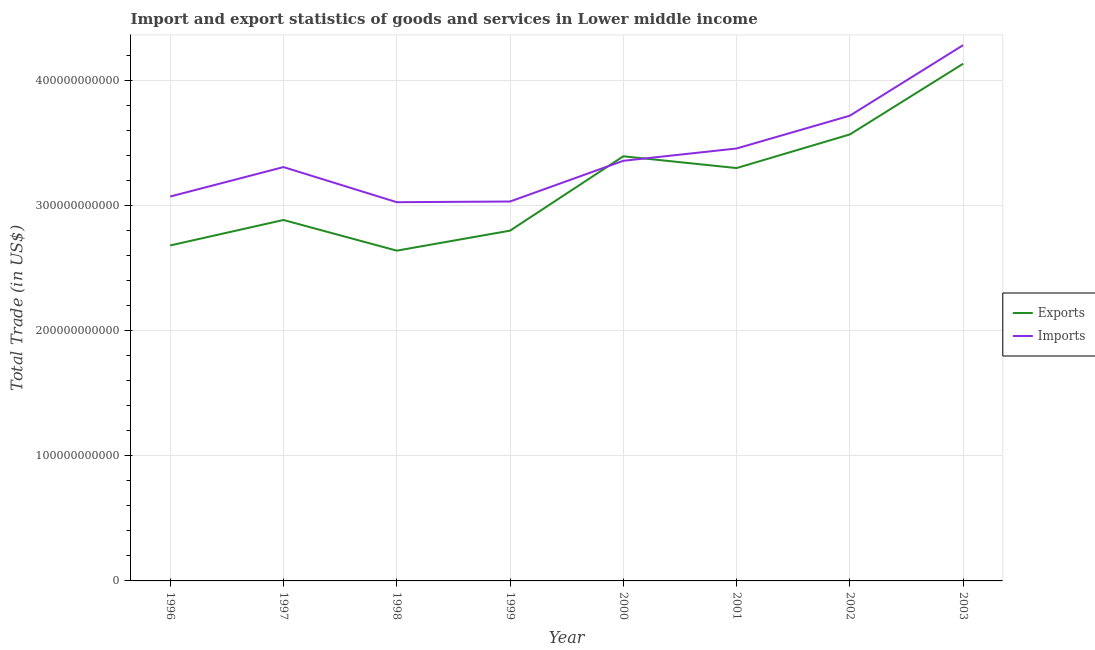How many different coloured lines are there?
Offer a terse response. 2. Does the line corresponding to imports of goods and services intersect with the line corresponding to export of goods and services?
Provide a succinct answer. Yes. What is the export of goods and services in 2002?
Offer a very short reply. 3.57e+11. Across all years, what is the maximum export of goods and services?
Offer a terse response. 4.14e+11. Across all years, what is the minimum imports of goods and services?
Make the answer very short. 3.03e+11. What is the total export of goods and services in the graph?
Your answer should be compact. 2.54e+12. What is the difference between the imports of goods and services in 1999 and that in 2001?
Provide a short and direct response. -4.24e+1. What is the difference between the export of goods and services in 1996 and the imports of goods and services in 2003?
Ensure brevity in your answer.  -1.60e+11. What is the average export of goods and services per year?
Make the answer very short. 3.18e+11. In the year 1997, what is the difference between the imports of goods and services and export of goods and services?
Make the answer very short. 4.23e+1. What is the ratio of the export of goods and services in 1996 to that in 2001?
Offer a very short reply. 0.81. What is the difference between the highest and the second highest export of goods and services?
Your response must be concise. 5.65e+1. What is the difference between the highest and the lowest export of goods and services?
Offer a terse response. 1.49e+11. Is the sum of the imports of goods and services in 2002 and 2003 greater than the maximum export of goods and services across all years?
Give a very brief answer. Yes. Does the imports of goods and services monotonically increase over the years?
Offer a very short reply. No. How many lines are there?
Your answer should be very brief. 2. How many years are there in the graph?
Give a very brief answer. 8. What is the difference between two consecutive major ticks on the Y-axis?
Ensure brevity in your answer.  1.00e+11. Are the values on the major ticks of Y-axis written in scientific E-notation?
Offer a very short reply. No. Does the graph contain any zero values?
Offer a very short reply. No. Where does the legend appear in the graph?
Your answer should be very brief. Center right. How many legend labels are there?
Offer a very short reply. 2. What is the title of the graph?
Provide a short and direct response. Import and export statistics of goods and services in Lower middle income. What is the label or title of the X-axis?
Keep it short and to the point. Year. What is the label or title of the Y-axis?
Your response must be concise. Total Trade (in US$). What is the Total Trade (in US$) in Exports in 1996?
Make the answer very short. 2.68e+11. What is the Total Trade (in US$) of Imports in 1996?
Ensure brevity in your answer.  3.07e+11. What is the Total Trade (in US$) in Exports in 1997?
Your response must be concise. 2.89e+11. What is the Total Trade (in US$) of Imports in 1997?
Offer a very short reply. 3.31e+11. What is the Total Trade (in US$) in Exports in 1998?
Provide a succinct answer. 2.64e+11. What is the Total Trade (in US$) of Imports in 1998?
Offer a terse response. 3.03e+11. What is the Total Trade (in US$) in Exports in 1999?
Ensure brevity in your answer.  2.80e+11. What is the Total Trade (in US$) in Imports in 1999?
Provide a succinct answer. 3.03e+11. What is the Total Trade (in US$) of Exports in 2000?
Provide a short and direct response. 3.40e+11. What is the Total Trade (in US$) of Imports in 2000?
Offer a very short reply. 3.36e+11. What is the Total Trade (in US$) of Exports in 2001?
Offer a terse response. 3.30e+11. What is the Total Trade (in US$) in Imports in 2001?
Your response must be concise. 3.46e+11. What is the Total Trade (in US$) of Exports in 2002?
Ensure brevity in your answer.  3.57e+11. What is the Total Trade (in US$) in Imports in 2002?
Offer a very short reply. 3.72e+11. What is the Total Trade (in US$) in Exports in 2003?
Your answer should be very brief. 4.14e+11. What is the Total Trade (in US$) in Imports in 2003?
Your answer should be very brief. 4.28e+11. Across all years, what is the maximum Total Trade (in US$) of Exports?
Provide a short and direct response. 4.14e+11. Across all years, what is the maximum Total Trade (in US$) of Imports?
Offer a very short reply. 4.28e+11. Across all years, what is the minimum Total Trade (in US$) in Exports?
Your answer should be very brief. 2.64e+11. Across all years, what is the minimum Total Trade (in US$) in Imports?
Provide a short and direct response. 3.03e+11. What is the total Total Trade (in US$) in Exports in the graph?
Provide a short and direct response. 2.54e+12. What is the total Total Trade (in US$) in Imports in the graph?
Provide a succinct answer. 2.73e+12. What is the difference between the Total Trade (in US$) of Exports in 1996 and that in 1997?
Offer a very short reply. -2.04e+1. What is the difference between the Total Trade (in US$) in Imports in 1996 and that in 1997?
Make the answer very short. -2.36e+1. What is the difference between the Total Trade (in US$) of Exports in 1996 and that in 1998?
Your answer should be very brief. 4.16e+09. What is the difference between the Total Trade (in US$) of Imports in 1996 and that in 1998?
Ensure brevity in your answer.  4.52e+09. What is the difference between the Total Trade (in US$) of Exports in 1996 and that in 1999?
Give a very brief answer. -1.18e+1. What is the difference between the Total Trade (in US$) in Imports in 1996 and that in 1999?
Provide a short and direct response. 3.98e+09. What is the difference between the Total Trade (in US$) of Exports in 1996 and that in 2000?
Provide a short and direct response. -7.13e+1. What is the difference between the Total Trade (in US$) of Imports in 1996 and that in 2000?
Ensure brevity in your answer.  -2.86e+1. What is the difference between the Total Trade (in US$) of Exports in 1996 and that in 2001?
Make the answer very short. -6.19e+1. What is the difference between the Total Trade (in US$) of Imports in 1996 and that in 2001?
Provide a short and direct response. -3.84e+1. What is the difference between the Total Trade (in US$) of Exports in 1996 and that in 2002?
Offer a very short reply. -8.88e+1. What is the difference between the Total Trade (in US$) of Imports in 1996 and that in 2002?
Offer a very short reply. -6.47e+1. What is the difference between the Total Trade (in US$) of Exports in 1996 and that in 2003?
Give a very brief answer. -1.45e+11. What is the difference between the Total Trade (in US$) in Imports in 1996 and that in 2003?
Ensure brevity in your answer.  -1.21e+11. What is the difference between the Total Trade (in US$) of Exports in 1997 and that in 1998?
Give a very brief answer. 2.45e+1. What is the difference between the Total Trade (in US$) of Imports in 1997 and that in 1998?
Your answer should be very brief. 2.81e+1. What is the difference between the Total Trade (in US$) of Exports in 1997 and that in 1999?
Your answer should be compact. 8.53e+09. What is the difference between the Total Trade (in US$) of Imports in 1997 and that in 1999?
Ensure brevity in your answer.  2.75e+1. What is the difference between the Total Trade (in US$) of Exports in 1997 and that in 2000?
Ensure brevity in your answer.  -5.09e+1. What is the difference between the Total Trade (in US$) in Imports in 1997 and that in 2000?
Keep it short and to the point. -5.03e+09. What is the difference between the Total Trade (in US$) in Exports in 1997 and that in 2001?
Offer a very short reply. -4.15e+1. What is the difference between the Total Trade (in US$) in Imports in 1997 and that in 2001?
Offer a terse response. -1.49e+1. What is the difference between the Total Trade (in US$) of Exports in 1997 and that in 2002?
Offer a terse response. -6.84e+1. What is the difference between the Total Trade (in US$) in Imports in 1997 and that in 2002?
Your response must be concise. -4.11e+1. What is the difference between the Total Trade (in US$) in Exports in 1997 and that in 2003?
Keep it short and to the point. -1.25e+11. What is the difference between the Total Trade (in US$) in Imports in 1997 and that in 2003?
Your response must be concise. -9.75e+1. What is the difference between the Total Trade (in US$) of Exports in 1998 and that in 1999?
Give a very brief answer. -1.60e+1. What is the difference between the Total Trade (in US$) in Imports in 1998 and that in 1999?
Offer a terse response. -5.44e+08. What is the difference between the Total Trade (in US$) of Exports in 1998 and that in 2000?
Make the answer very short. -7.55e+1. What is the difference between the Total Trade (in US$) of Imports in 1998 and that in 2000?
Offer a very short reply. -3.31e+1. What is the difference between the Total Trade (in US$) in Exports in 1998 and that in 2001?
Provide a succinct answer. -6.60e+1. What is the difference between the Total Trade (in US$) of Imports in 1998 and that in 2001?
Ensure brevity in your answer.  -4.29e+1. What is the difference between the Total Trade (in US$) in Exports in 1998 and that in 2002?
Give a very brief answer. -9.29e+1. What is the difference between the Total Trade (in US$) of Imports in 1998 and that in 2002?
Offer a terse response. -6.92e+1. What is the difference between the Total Trade (in US$) of Exports in 1998 and that in 2003?
Keep it short and to the point. -1.49e+11. What is the difference between the Total Trade (in US$) of Imports in 1998 and that in 2003?
Your answer should be compact. -1.26e+11. What is the difference between the Total Trade (in US$) in Exports in 1999 and that in 2000?
Provide a short and direct response. -5.95e+1. What is the difference between the Total Trade (in US$) of Imports in 1999 and that in 2000?
Your answer should be very brief. -3.26e+1. What is the difference between the Total Trade (in US$) in Exports in 1999 and that in 2001?
Make the answer very short. -5.01e+1. What is the difference between the Total Trade (in US$) in Imports in 1999 and that in 2001?
Offer a terse response. -4.24e+1. What is the difference between the Total Trade (in US$) in Exports in 1999 and that in 2002?
Provide a short and direct response. -7.69e+1. What is the difference between the Total Trade (in US$) of Imports in 1999 and that in 2002?
Offer a terse response. -6.86e+1. What is the difference between the Total Trade (in US$) of Exports in 1999 and that in 2003?
Provide a short and direct response. -1.33e+11. What is the difference between the Total Trade (in US$) in Imports in 1999 and that in 2003?
Your response must be concise. -1.25e+11. What is the difference between the Total Trade (in US$) of Exports in 2000 and that in 2001?
Provide a succinct answer. 9.41e+09. What is the difference between the Total Trade (in US$) of Imports in 2000 and that in 2001?
Your answer should be compact. -9.82e+09. What is the difference between the Total Trade (in US$) of Exports in 2000 and that in 2002?
Your answer should be compact. -1.75e+1. What is the difference between the Total Trade (in US$) in Imports in 2000 and that in 2002?
Make the answer very short. -3.61e+1. What is the difference between the Total Trade (in US$) in Exports in 2000 and that in 2003?
Make the answer very short. -7.40e+1. What is the difference between the Total Trade (in US$) in Imports in 2000 and that in 2003?
Your answer should be compact. -9.25e+1. What is the difference between the Total Trade (in US$) in Exports in 2001 and that in 2002?
Your answer should be very brief. -2.69e+1. What is the difference between the Total Trade (in US$) of Imports in 2001 and that in 2002?
Keep it short and to the point. -2.62e+1. What is the difference between the Total Trade (in US$) of Exports in 2001 and that in 2003?
Give a very brief answer. -8.34e+1. What is the difference between the Total Trade (in US$) in Imports in 2001 and that in 2003?
Offer a very short reply. -8.26e+1. What is the difference between the Total Trade (in US$) in Exports in 2002 and that in 2003?
Ensure brevity in your answer.  -5.65e+1. What is the difference between the Total Trade (in US$) of Imports in 2002 and that in 2003?
Provide a succinct answer. -5.64e+1. What is the difference between the Total Trade (in US$) of Exports in 1996 and the Total Trade (in US$) of Imports in 1997?
Provide a succinct answer. -6.27e+1. What is the difference between the Total Trade (in US$) in Exports in 1996 and the Total Trade (in US$) in Imports in 1998?
Your answer should be compact. -3.46e+1. What is the difference between the Total Trade (in US$) in Exports in 1996 and the Total Trade (in US$) in Imports in 1999?
Make the answer very short. -3.51e+1. What is the difference between the Total Trade (in US$) of Exports in 1996 and the Total Trade (in US$) of Imports in 2000?
Offer a terse response. -6.77e+1. What is the difference between the Total Trade (in US$) in Exports in 1996 and the Total Trade (in US$) in Imports in 2001?
Your answer should be compact. -7.75e+1. What is the difference between the Total Trade (in US$) of Exports in 1996 and the Total Trade (in US$) of Imports in 2002?
Keep it short and to the point. -1.04e+11. What is the difference between the Total Trade (in US$) in Exports in 1996 and the Total Trade (in US$) in Imports in 2003?
Your response must be concise. -1.60e+11. What is the difference between the Total Trade (in US$) in Exports in 1997 and the Total Trade (in US$) in Imports in 1998?
Provide a short and direct response. -1.42e+1. What is the difference between the Total Trade (in US$) of Exports in 1997 and the Total Trade (in US$) of Imports in 1999?
Offer a very short reply. -1.48e+1. What is the difference between the Total Trade (in US$) in Exports in 1997 and the Total Trade (in US$) in Imports in 2000?
Give a very brief answer. -4.73e+1. What is the difference between the Total Trade (in US$) in Exports in 1997 and the Total Trade (in US$) in Imports in 2001?
Your answer should be very brief. -5.72e+1. What is the difference between the Total Trade (in US$) of Exports in 1997 and the Total Trade (in US$) of Imports in 2002?
Make the answer very short. -8.34e+1. What is the difference between the Total Trade (in US$) of Exports in 1997 and the Total Trade (in US$) of Imports in 2003?
Offer a terse response. -1.40e+11. What is the difference between the Total Trade (in US$) of Exports in 1998 and the Total Trade (in US$) of Imports in 1999?
Ensure brevity in your answer.  -3.93e+1. What is the difference between the Total Trade (in US$) in Exports in 1998 and the Total Trade (in US$) in Imports in 2000?
Keep it short and to the point. -7.19e+1. What is the difference between the Total Trade (in US$) in Exports in 1998 and the Total Trade (in US$) in Imports in 2001?
Your response must be concise. -8.17e+1. What is the difference between the Total Trade (in US$) in Exports in 1998 and the Total Trade (in US$) in Imports in 2002?
Keep it short and to the point. -1.08e+11. What is the difference between the Total Trade (in US$) of Exports in 1998 and the Total Trade (in US$) of Imports in 2003?
Offer a terse response. -1.64e+11. What is the difference between the Total Trade (in US$) of Exports in 1999 and the Total Trade (in US$) of Imports in 2000?
Keep it short and to the point. -5.59e+1. What is the difference between the Total Trade (in US$) of Exports in 1999 and the Total Trade (in US$) of Imports in 2001?
Make the answer very short. -6.57e+1. What is the difference between the Total Trade (in US$) in Exports in 1999 and the Total Trade (in US$) in Imports in 2002?
Ensure brevity in your answer.  -9.19e+1. What is the difference between the Total Trade (in US$) in Exports in 1999 and the Total Trade (in US$) in Imports in 2003?
Offer a very short reply. -1.48e+11. What is the difference between the Total Trade (in US$) in Exports in 2000 and the Total Trade (in US$) in Imports in 2001?
Offer a terse response. -6.23e+09. What is the difference between the Total Trade (in US$) in Exports in 2000 and the Total Trade (in US$) in Imports in 2002?
Your response must be concise. -3.25e+1. What is the difference between the Total Trade (in US$) in Exports in 2000 and the Total Trade (in US$) in Imports in 2003?
Offer a very short reply. -8.89e+1. What is the difference between the Total Trade (in US$) in Exports in 2001 and the Total Trade (in US$) in Imports in 2002?
Make the answer very short. -4.19e+1. What is the difference between the Total Trade (in US$) of Exports in 2001 and the Total Trade (in US$) of Imports in 2003?
Ensure brevity in your answer.  -9.83e+1. What is the difference between the Total Trade (in US$) of Exports in 2002 and the Total Trade (in US$) of Imports in 2003?
Your answer should be compact. -7.14e+1. What is the average Total Trade (in US$) in Exports per year?
Keep it short and to the point. 3.18e+11. What is the average Total Trade (in US$) in Imports per year?
Offer a very short reply. 3.41e+11. In the year 1996, what is the difference between the Total Trade (in US$) in Exports and Total Trade (in US$) in Imports?
Make the answer very short. -3.91e+1. In the year 1997, what is the difference between the Total Trade (in US$) in Exports and Total Trade (in US$) in Imports?
Your answer should be compact. -4.23e+1. In the year 1998, what is the difference between the Total Trade (in US$) of Exports and Total Trade (in US$) of Imports?
Give a very brief answer. -3.88e+1. In the year 1999, what is the difference between the Total Trade (in US$) of Exports and Total Trade (in US$) of Imports?
Ensure brevity in your answer.  -2.33e+1. In the year 2000, what is the difference between the Total Trade (in US$) of Exports and Total Trade (in US$) of Imports?
Provide a short and direct response. 3.59e+09. In the year 2001, what is the difference between the Total Trade (in US$) in Exports and Total Trade (in US$) in Imports?
Provide a succinct answer. -1.56e+1. In the year 2002, what is the difference between the Total Trade (in US$) in Exports and Total Trade (in US$) in Imports?
Offer a terse response. -1.50e+1. In the year 2003, what is the difference between the Total Trade (in US$) of Exports and Total Trade (in US$) of Imports?
Make the answer very short. -1.48e+1. What is the ratio of the Total Trade (in US$) of Exports in 1996 to that in 1997?
Make the answer very short. 0.93. What is the ratio of the Total Trade (in US$) in Imports in 1996 to that in 1997?
Keep it short and to the point. 0.93. What is the ratio of the Total Trade (in US$) of Exports in 1996 to that in 1998?
Provide a succinct answer. 1.02. What is the ratio of the Total Trade (in US$) in Imports in 1996 to that in 1998?
Ensure brevity in your answer.  1.01. What is the ratio of the Total Trade (in US$) of Exports in 1996 to that in 1999?
Offer a terse response. 0.96. What is the ratio of the Total Trade (in US$) in Imports in 1996 to that in 1999?
Provide a short and direct response. 1.01. What is the ratio of the Total Trade (in US$) of Exports in 1996 to that in 2000?
Your answer should be very brief. 0.79. What is the ratio of the Total Trade (in US$) of Imports in 1996 to that in 2000?
Ensure brevity in your answer.  0.91. What is the ratio of the Total Trade (in US$) in Exports in 1996 to that in 2001?
Keep it short and to the point. 0.81. What is the ratio of the Total Trade (in US$) of Exports in 1996 to that in 2002?
Offer a terse response. 0.75. What is the ratio of the Total Trade (in US$) in Imports in 1996 to that in 2002?
Offer a very short reply. 0.83. What is the ratio of the Total Trade (in US$) of Exports in 1996 to that in 2003?
Provide a short and direct response. 0.65. What is the ratio of the Total Trade (in US$) of Imports in 1996 to that in 2003?
Give a very brief answer. 0.72. What is the ratio of the Total Trade (in US$) in Exports in 1997 to that in 1998?
Your answer should be very brief. 1.09. What is the ratio of the Total Trade (in US$) of Imports in 1997 to that in 1998?
Provide a short and direct response. 1.09. What is the ratio of the Total Trade (in US$) of Exports in 1997 to that in 1999?
Your answer should be very brief. 1.03. What is the ratio of the Total Trade (in US$) of Imports in 1997 to that in 1999?
Offer a terse response. 1.09. What is the ratio of the Total Trade (in US$) of Exports in 1997 to that in 2000?
Provide a succinct answer. 0.85. What is the ratio of the Total Trade (in US$) of Exports in 1997 to that in 2001?
Make the answer very short. 0.87. What is the ratio of the Total Trade (in US$) of Exports in 1997 to that in 2002?
Offer a very short reply. 0.81. What is the ratio of the Total Trade (in US$) in Imports in 1997 to that in 2002?
Provide a short and direct response. 0.89. What is the ratio of the Total Trade (in US$) in Exports in 1997 to that in 2003?
Offer a terse response. 0.7. What is the ratio of the Total Trade (in US$) in Imports in 1997 to that in 2003?
Offer a terse response. 0.77. What is the ratio of the Total Trade (in US$) in Exports in 1998 to that in 1999?
Provide a short and direct response. 0.94. What is the ratio of the Total Trade (in US$) in Imports in 1998 to that in 1999?
Your response must be concise. 1. What is the ratio of the Total Trade (in US$) of Imports in 1998 to that in 2000?
Keep it short and to the point. 0.9. What is the ratio of the Total Trade (in US$) in Exports in 1998 to that in 2001?
Your response must be concise. 0.8. What is the ratio of the Total Trade (in US$) of Imports in 1998 to that in 2001?
Offer a terse response. 0.88. What is the ratio of the Total Trade (in US$) of Exports in 1998 to that in 2002?
Your answer should be compact. 0.74. What is the ratio of the Total Trade (in US$) of Imports in 1998 to that in 2002?
Offer a very short reply. 0.81. What is the ratio of the Total Trade (in US$) of Exports in 1998 to that in 2003?
Provide a succinct answer. 0.64. What is the ratio of the Total Trade (in US$) of Imports in 1998 to that in 2003?
Offer a terse response. 0.71. What is the ratio of the Total Trade (in US$) in Exports in 1999 to that in 2000?
Give a very brief answer. 0.82. What is the ratio of the Total Trade (in US$) in Imports in 1999 to that in 2000?
Your answer should be very brief. 0.9. What is the ratio of the Total Trade (in US$) in Exports in 1999 to that in 2001?
Make the answer very short. 0.85. What is the ratio of the Total Trade (in US$) of Imports in 1999 to that in 2001?
Your answer should be compact. 0.88. What is the ratio of the Total Trade (in US$) of Exports in 1999 to that in 2002?
Your answer should be very brief. 0.78. What is the ratio of the Total Trade (in US$) of Imports in 1999 to that in 2002?
Give a very brief answer. 0.82. What is the ratio of the Total Trade (in US$) in Exports in 1999 to that in 2003?
Your answer should be compact. 0.68. What is the ratio of the Total Trade (in US$) of Imports in 1999 to that in 2003?
Your answer should be very brief. 0.71. What is the ratio of the Total Trade (in US$) in Exports in 2000 to that in 2001?
Your answer should be compact. 1.03. What is the ratio of the Total Trade (in US$) in Imports in 2000 to that in 2001?
Offer a terse response. 0.97. What is the ratio of the Total Trade (in US$) of Exports in 2000 to that in 2002?
Provide a succinct answer. 0.95. What is the ratio of the Total Trade (in US$) of Imports in 2000 to that in 2002?
Your response must be concise. 0.9. What is the ratio of the Total Trade (in US$) in Exports in 2000 to that in 2003?
Provide a short and direct response. 0.82. What is the ratio of the Total Trade (in US$) in Imports in 2000 to that in 2003?
Provide a succinct answer. 0.78. What is the ratio of the Total Trade (in US$) of Exports in 2001 to that in 2002?
Your answer should be very brief. 0.92. What is the ratio of the Total Trade (in US$) in Imports in 2001 to that in 2002?
Your response must be concise. 0.93. What is the ratio of the Total Trade (in US$) of Exports in 2001 to that in 2003?
Your answer should be compact. 0.8. What is the ratio of the Total Trade (in US$) of Imports in 2001 to that in 2003?
Your answer should be very brief. 0.81. What is the ratio of the Total Trade (in US$) in Exports in 2002 to that in 2003?
Give a very brief answer. 0.86. What is the ratio of the Total Trade (in US$) of Imports in 2002 to that in 2003?
Provide a succinct answer. 0.87. What is the difference between the highest and the second highest Total Trade (in US$) of Exports?
Make the answer very short. 5.65e+1. What is the difference between the highest and the second highest Total Trade (in US$) of Imports?
Provide a succinct answer. 5.64e+1. What is the difference between the highest and the lowest Total Trade (in US$) of Exports?
Your answer should be very brief. 1.49e+11. What is the difference between the highest and the lowest Total Trade (in US$) of Imports?
Offer a terse response. 1.26e+11. 